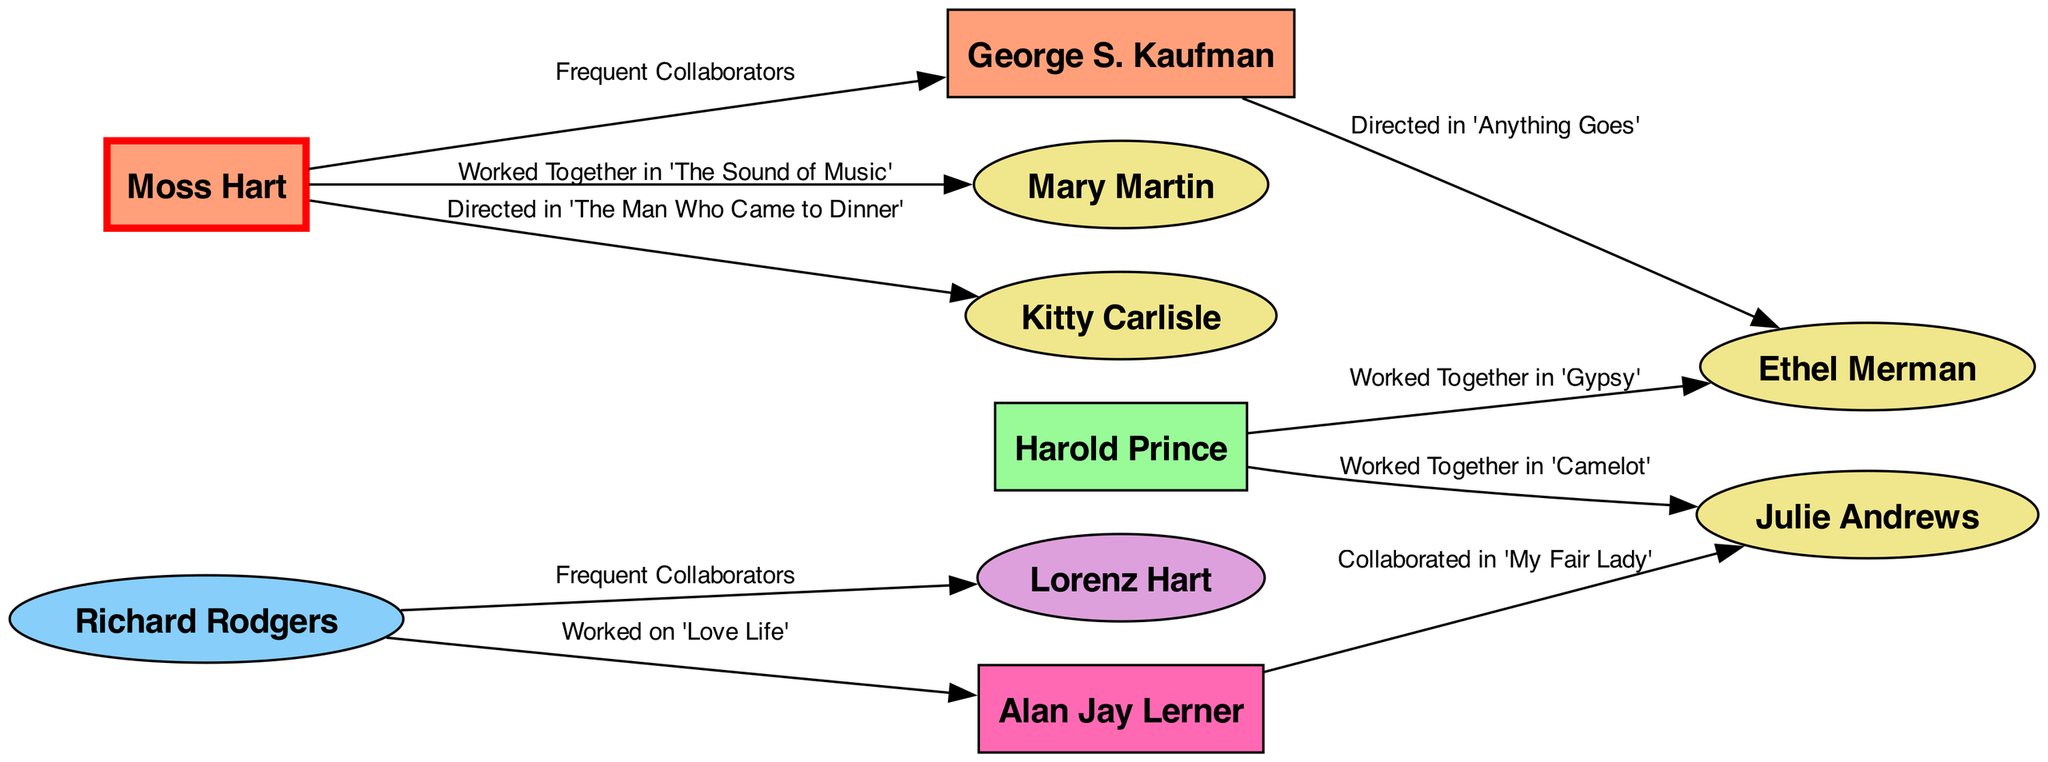What is the total number of nodes in the diagram? The diagram lists 10 distinct individuals or entities in the nodes section. By counting them, we find that the total is 10.
Answer: 10 Who directed Mary Martin according to the diagram? The edge connecting Moss Hart to Mary Martin indicates that he worked with her in 'The Sound of Music', making him her director in that production.
Answer: Moss Hart Which composer frequently collaborated with Lorenz Hart? The edge connecting Richard Rodgers to Lorenz Hart signifies that they worked together often, indicating a frequent collaboration.
Answer: Richard Rodgers How many actors are in the diagram? The nodes list three actors: Mary Martin, Ethel Merman, and Kitty Carlisle, which can be counted directly as distinct individuals with the role of actor.
Answer: 4 Name a production in which Ethel Merman was directed by George S. Kaufman. The edge in the diagram specifies that George S. Kaufman directed Ethel Merman in the production of 'Anything Goes', which identifies the specific work mentioned.
Answer: Anything Goes Which actor collaborated with both Harold Prince and Alan Jay Lerner? The diagram shows that Julie Andrews worked with Harold Prince in 'Camelot' and also collaborated with Alan Jay Lerner in 'My Fair Lady', making her the common actor.
Answer: Julie Andrews Who has the most connections in terms of collaborative relationships within the diagram? By examining the edges, Moss Hart has three direct connections: one to George S. Kaufman, one to Mary Martin, and one to Kitty Carlisle, which indicates a significant presence in the network of collaborations.
Answer: Moss Hart What is the relationship type between Richard Rodgers and Alan Jay Lerner? The edge connecting Richard Rodgers to Alan Jay Lerner specifies that they worked on 'Love Life', which describes the nature of their collaborative relationship.
Answer: Worked on 'Love Life' Which two individuals worked together on 'Gypsy'? The edge directly connects Harold Prince to Ethel Merman, with the label indicating that they collaborated on the production 'Gypsy', naming the specific project.
Answer: Harold Prince and Ethel Merman 